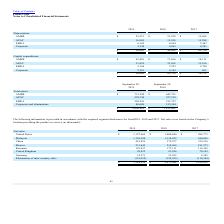According to Plexus's financial document, What was the depreciation from AMER in 2017? According to the financial document, 19,694 (in thousands). The relevant text states: "AMER $ 22,531 $ 21,224 $ 19,694..." Also, What was the depreciation from APAC in 2018? According to the financial document, 15,954 (in thousands). The relevant text states: "APAC 16,905 15,954 15,588..." Also, What was the Corporate depreciation in 2019? According to the financial document, 5,344 (in thousands). The relevant text states: "Corporate 5,344 4,863 4,581..." Also, How many years did depreciation from APAC exceed $15,000 thousand instead? Counting the relevant items in the document: 2019, 2018, 2017, I find 3 instances. The key data points involved are: 2017, 2018, 2019. Also, can you calculate: What was the change in Corporate Depreciation between 2018 and 2019? Based on the calculation: 5,344-4,863, the result is 481 (in thousands). This is based on the information: "Corporate 5,344 4,863 4,581 Corporate 5,344 4,863 4,581..." The key data points involved are: 4,863, 5,344. Also, can you calculate: What was the percentage change in the total depreciation between 2017 and 2018? To answer this question, I need to perform calculations using the financial data. The calculation is: (48,095-45,330)/45,330, which equals 6.1 (percentage). This is based on the information: "$ 50,885 $ 48,095 $ 45,330 $ 50,885 $ 48,095 $ 45,330..." The key data points involved are: 45,330, 48,095. 